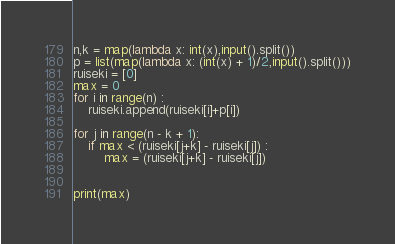<code> <loc_0><loc_0><loc_500><loc_500><_Python_>n,k = map(lambda x: int(x),input().split())
p = list(map(lambda x: (int(x) + 1)/2,input().split()))
ruiseki = [0]
max = 0
for i in range(n) :
    ruiseki.append(ruiseki[i]+p[i])

for j in range(n - k + 1):
    if max < (ruiseki[j+k] - ruiseki[j]) :
        max = (ruiseki[j+k] - ruiseki[j])


print(max)
</code> 